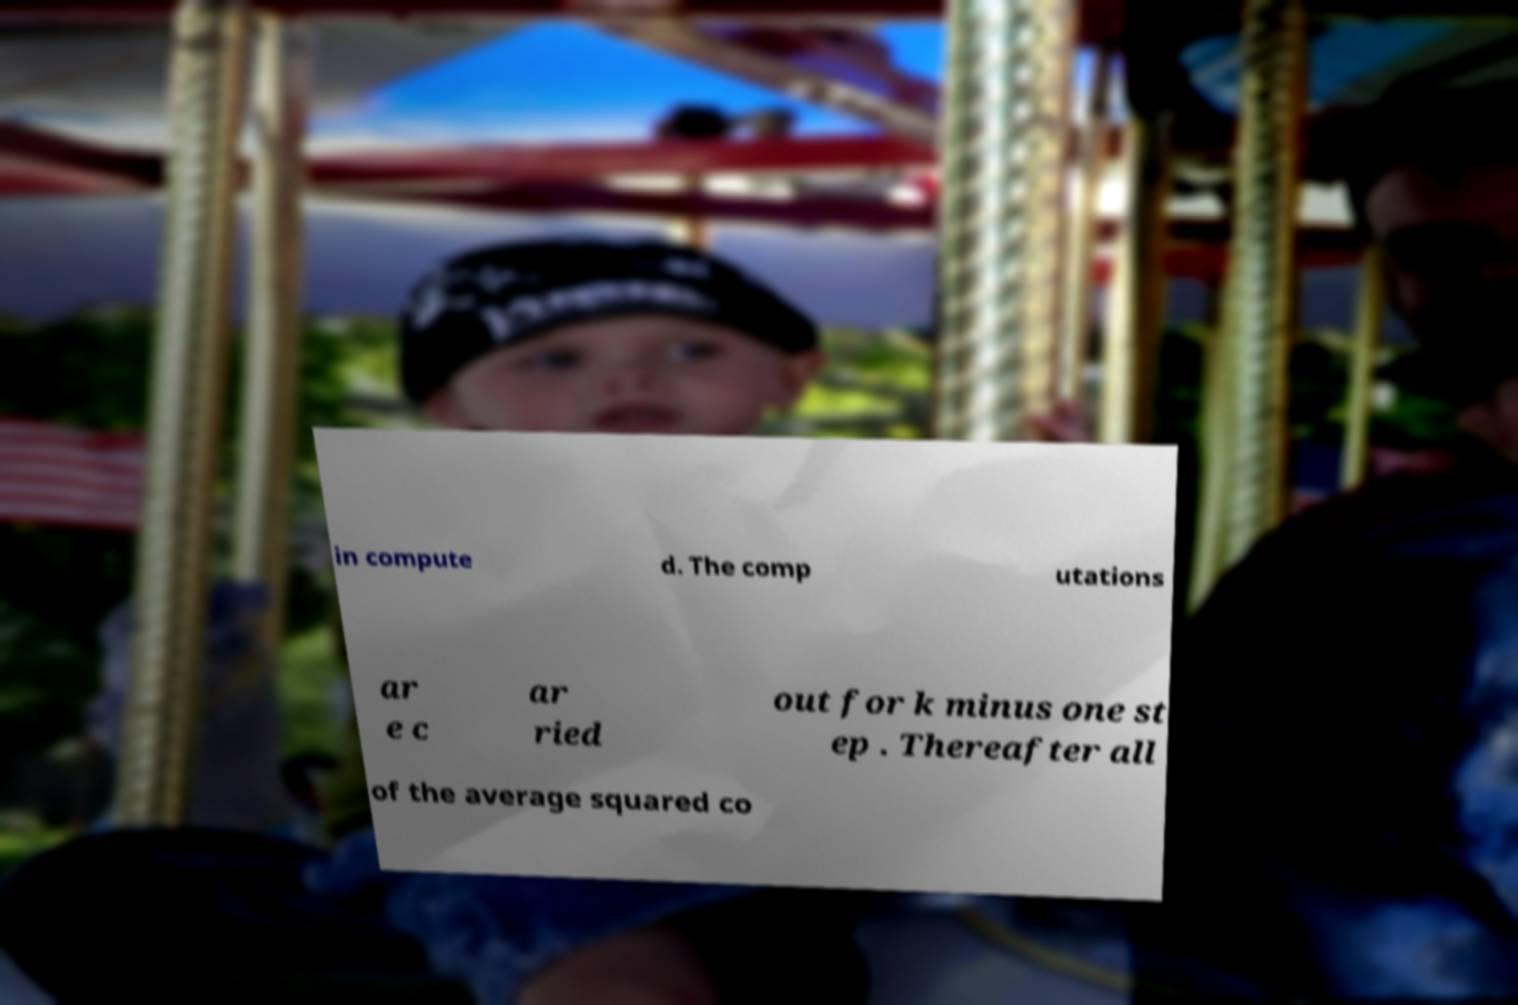What messages or text are displayed in this image? I need them in a readable, typed format. in compute d. The comp utations ar e c ar ried out for k minus one st ep . Thereafter all of the average squared co 